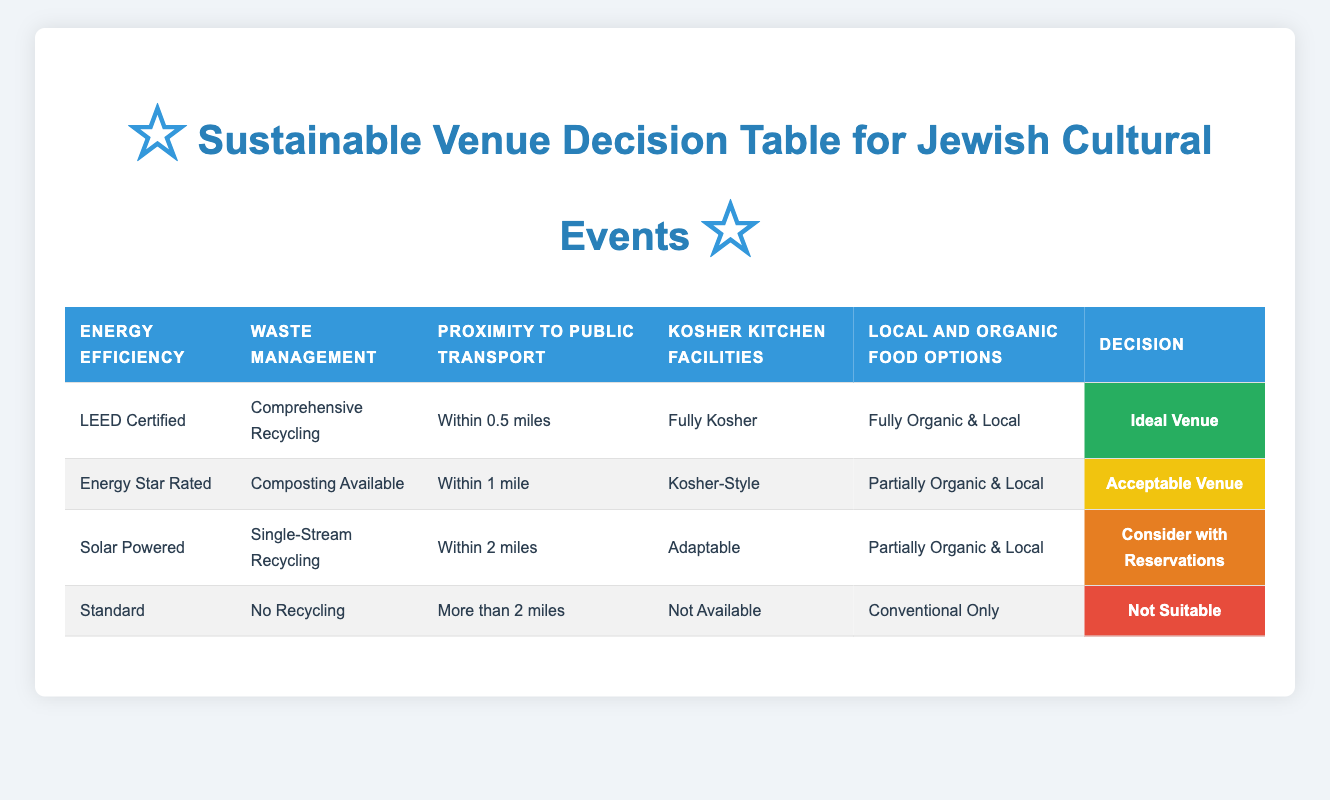What is the condition for an "Ideal Venue"? An "Ideal Venue" is defined by having all of the following conditions: Energy Efficiency as "LEED Certified," Waste Management as "Comprehensive Recycling," Proximity to Public Transport as "Within 0.5 miles," Kosher Kitchen Facilities as "Fully Kosher," and Local and Organic Food Options as "Fully Organic & Local."
Answer: LEED Certified, Comprehensive Recycling, Within 0.5 miles, Fully Kosher, Fully Organic & Local How many venues are classified as "Acceptable Venue"? There is one venue classified as "Acceptable Venue," which meets the criteria of being "Energy Star Rated," having "Composting Available," being "Within 1 mile," having "Kosher-Style" kitchen facilities, and offering "Partially Organic & Local" food options.
Answer: 1 Is there a venue that is "Not Suitable"? Yes, there is one venue classified as "Not Suitable." It has "Standard" energy efficiency, "No Recycling" for waste management, is located "More than 2 miles" from public transport, has "Not Available" kosher kitchen facilities, and offers "Conventional Only" food options.
Answer: Yes How many different criteria are specified for waste management? The table lists four different options for waste management: "Comprehensive Recycling," "Composting Available," "Single-Stream Recycling," and "No Recycling."
Answer: 4 If a venue is "Solar Powered," which categories of waste management might it have? A venue that is "Solar Powered" may have "Single-Stream Recycling" or "No Recycling" as its waste management option, based on the conditions outlined in the table. According to one rule, "Solar Powered" venues that have "Single-Stream Recycling" would be classified as "Consider with Reservations."
Answer: Single-Stream Recycling or No Recycling What is the most restrictive proximity condition for an "Ideal Venue"? The most restrictive proximity condition for an "Ideal Venue" is "Within 0.5 miles," which is the only proximity condition listed under this category. Other categories allow venues to be farther away, such as "Within 1 mile" and "Within 2 miles."
Answer: Within 0.5 miles How can we compare the local and organic food options offered by different venues? There are three levels of local and organic food options: "Fully Organic & Local," "Partially Organic & Local," and "Conventional Only." Each rule for venue classification relates to a combination of food options and other criteria. The "Ideal Venue" requires full organic and local options, while the "Acceptable Venue" and "Consider with Reservations" may have partial options.
Answer: Comparison available among three categories Which type of venue requires both "Single-Stream Recycling" and "Within 2 miles"? The venue that requires "Single-Stream Recycling" and is "Within 2 miles" would be categorized as "Consider with Reservations," specifically for venues that are "Solar Powered" and have "Adaptable" kosher facilities, alongside offering "Partially Organic & Local" food options.
Answer: Consider with Reservations What combination leads to an "Ideal Venue"? An "Ideal Venue" requires specific combinations: "LEED Certified" energy efficiency, "Comprehensive Recycling" for waste management, proximity of "Within 0.5 miles," "Fully Kosher" kitchen facilities, and "Fully Organic & Local" food options. This specific collection of characteristics defines the best venue for events.
Answer: LEED Certified, Comprehensive Recycling, Within 0.5 miles, Fully Kosher, Fully Organic & Local 